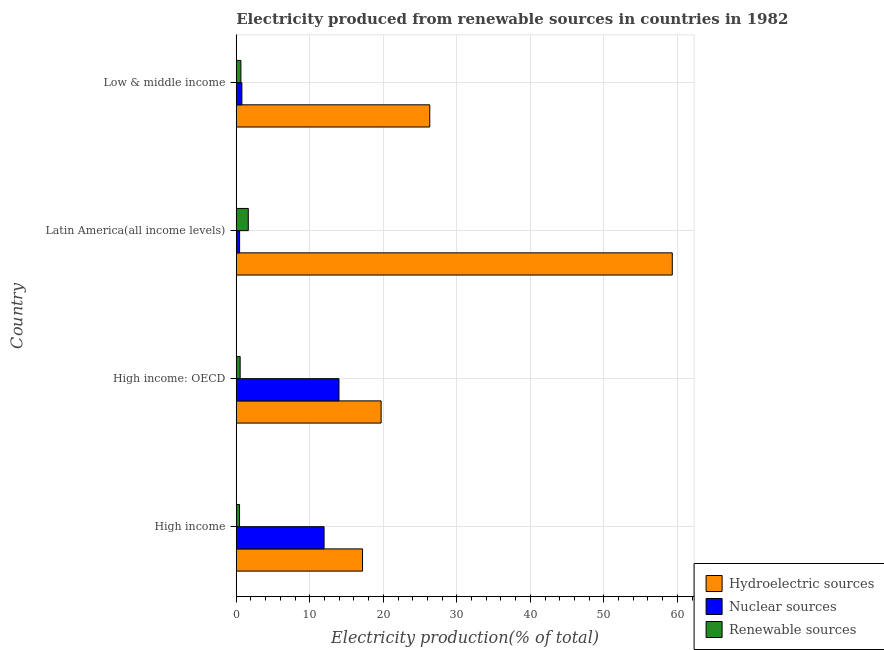How many different coloured bars are there?
Offer a very short reply. 3. Are the number of bars per tick equal to the number of legend labels?
Keep it short and to the point. Yes. Are the number of bars on each tick of the Y-axis equal?
Offer a very short reply. Yes. How many bars are there on the 3rd tick from the top?
Your response must be concise. 3. What is the label of the 4th group of bars from the top?
Make the answer very short. High income. In how many cases, is the number of bars for a given country not equal to the number of legend labels?
Ensure brevity in your answer.  0. What is the percentage of electricity produced by hydroelectric sources in High income?
Provide a succinct answer. 17.18. Across all countries, what is the maximum percentage of electricity produced by hydroelectric sources?
Ensure brevity in your answer.  59.31. Across all countries, what is the minimum percentage of electricity produced by renewable sources?
Give a very brief answer. 0.45. In which country was the percentage of electricity produced by renewable sources maximum?
Offer a very short reply. Latin America(all income levels). What is the total percentage of electricity produced by nuclear sources in the graph?
Ensure brevity in your answer.  27.14. What is the difference between the percentage of electricity produced by hydroelectric sources in High income and that in Latin America(all income levels)?
Provide a succinct answer. -42.13. What is the difference between the percentage of electricity produced by renewable sources in High income and the percentage of electricity produced by hydroelectric sources in Low & middle income?
Provide a succinct answer. -25.87. What is the average percentage of electricity produced by hydroelectric sources per country?
Provide a succinct answer. 30.63. What is the difference between the percentage of electricity produced by nuclear sources and percentage of electricity produced by hydroelectric sources in High income: OECD?
Your response must be concise. -5.73. What is the ratio of the percentage of electricity produced by hydroelectric sources in High income: OECD to that in Low & middle income?
Provide a short and direct response. 0.75. What is the difference between the highest and the second highest percentage of electricity produced by nuclear sources?
Keep it short and to the point. 2.03. What is the difference between the highest and the lowest percentage of electricity produced by renewable sources?
Give a very brief answer. 1.19. In how many countries, is the percentage of electricity produced by nuclear sources greater than the average percentage of electricity produced by nuclear sources taken over all countries?
Your answer should be compact. 2. What does the 2nd bar from the top in Latin America(all income levels) represents?
Provide a short and direct response. Nuclear sources. What does the 3rd bar from the bottom in High income represents?
Give a very brief answer. Renewable sources. How many bars are there?
Keep it short and to the point. 12. Are all the bars in the graph horizontal?
Provide a short and direct response. Yes. How many legend labels are there?
Give a very brief answer. 3. What is the title of the graph?
Offer a very short reply. Electricity produced from renewable sources in countries in 1982. What is the Electricity production(% of total) in Hydroelectric sources in High income?
Provide a succinct answer. 17.18. What is the Electricity production(% of total) of Nuclear sources in High income?
Give a very brief answer. 11.95. What is the Electricity production(% of total) in Renewable sources in High income?
Your answer should be very brief. 0.45. What is the Electricity production(% of total) of Hydroelectric sources in High income: OECD?
Your answer should be compact. 19.7. What is the Electricity production(% of total) of Nuclear sources in High income: OECD?
Your answer should be very brief. 13.97. What is the Electricity production(% of total) of Renewable sources in High income: OECD?
Provide a succinct answer. 0.53. What is the Electricity production(% of total) in Hydroelectric sources in Latin America(all income levels)?
Keep it short and to the point. 59.31. What is the Electricity production(% of total) in Nuclear sources in Latin America(all income levels)?
Provide a short and direct response. 0.45. What is the Electricity production(% of total) of Renewable sources in Latin America(all income levels)?
Offer a terse response. 1.64. What is the Electricity production(% of total) in Hydroelectric sources in Low & middle income?
Keep it short and to the point. 26.32. What is the Electricity production(% of total) of Nuclear sources in Low & middle income?
Your response must be concise. 0.77. What is the Electricity production(% of total) in Renewable sources in Low & middle income?
Your response must be concise. 0.63. Across all countries, what is the maximum Electricity production(% of total) of Hydroelectric sources?
Offer a terse response. 59.31. Across all countries, what is the maximum Electricity production(% of total) in Nuclear sources?
Offer a very short reply. 13.97. Across all countries, what is the maximum Electricity production(% of total) of Renewable sources?
Keep it short and to the point. 1.64. Across all countries, what is the minimum Electricity production(% of total) of Hydroelectric sources?
Offer a terse response. 17.18. Across all countries, what is the minimum Electricity production(% of total) of Nuclear sources?
Offer a terse response. 0.45. Across all countries, what is the minimum Electricity production(% of total) in Renewable sources?
Give a very brief answer. 0.45. What is the total Electricity production(% of total) of Hydroelectric sources in the graph?
Give a very brief answer. 122.51. What is the total Electricity production(% of total) of Nuclear sources in the graph?
Your answer should be very brief. 27.14. What is the total Electricity production(% of total) of Renewable sources in the graph?
Offer a very short reply. 3.25. What is the difference between the Electricity production(% of total) in Hydroelectric sources in High income and that in High income: OECD?
Your response must be concise. -2.53. What is the difference between the Electricity production(% of total) in Nuclear sources in High income and that in High income: OECD?
Your response must be concise. -2.03. What is the difference between the Electricity production(% of total) of Renewable sources in High income and that in High income: OECD?
Your response must be concise. -0.08. What is the difference between the Electricity production(% of total) in Hydroelectric sources in High income and that in Latin America(all income levels)?
Your answer should be compact. -42.13. What is the difference between the Electricity production(% of total) of Nuclear sources in High income and that in Latin America(all income levels)?
Offer a very short reply. 11.49. What is the difference between the Electricity production(% of total) in Renewable sources in High income and that in Latin America(all income levels)?
Ensure brevity in your answer.  -1.19. What is the difference between the Electricity production(% of total) of Hydroelectric sources in High income and that in Low & middle income?
Ensure brevity in your answer.  -9.14. What is the difference between the Electricity production(% of total) in Nuclear sources in High income and that in Low & middle income?
Give a very brief answer. 11.18. What is the difference between the Electricity production(% of total) in Renewable sources in High income and that in Low & middle income?
Offer a very short reply. -0.18. What is the difference between the Electricity production(% of total) of Hydroelectric sources in High income: OECD and that in Latin America(all income levels)?
Provide a short and direct response. -39.6. What is the difference between the Electricity production(% of total) of Nuclear sources in High income: OECD and that in Latin America(all income levels)?
Give a very brief answer. 13.52. What is the difference between the Electricity production(% of total) of Renewable sources in High income: OECD and that in Latin America(all income levels)?
Provide a short and direct response. -1.11. What is the difference between the Electricity production(% of total) of Hydroelectric sources in High income: OECD and that in Low & middle income?
Provide a short and direct response. -6.62. What is the difference between the Electricity production(% of total) in Nuclear sources in High income: OECD and that in Low & middle income?
Offer a very short reply. 13.21. What is the difference between the Electricity production(% of total) of Renewable sources in High income: OECD and that in Low & middle income?
Give a very brief answer. -0.1. What is the difference between the Electricity production(% of total) of Hydroelectric sources in Latin America(all income levels) and that in Low & middle income?
Keep it short and to the point. 32.99. What is the difference between the Electricity production(% of total) in Nuclear sources in Latin America(all income levels) and that in Low & middle income?
Offer a terse response. -0.31. What is the difference between the Electricity production(% of total) of Renewable sources in Latin America(all income levels) and that in Low & middle income?
Your answer should be compact. 1.01. What is the difference between the Electricity production(% of total) of Hydroelectric sources in High income and the Electricity production(% of total) of Nuclear sources in High income: OECD?
Ensure brevity in your answer.  3.2. What is the difference between the Electricity production(% of total) of Hydroelectric sources in High income and the Electricity production(% of total) of Renewable sources in High income: OECD?
Provide a succinct answer. 16.65. What is the difference between the Electricity production(% of total) in Nuclear sources in High income and the Electricity production(% of total) in Renewable sources in High income: OECD?
Your answer should be compact. 11.41. What is the difference between the Electricity production(% of total) of Hydroelectric sources in High income and the Electricity production(% of total) of Nuclear sources in Latin America(all income levels)?
Offer a very short reply. 16.72. What is the difference between the Electricity production(% of total) in Hydroelectric sources in High income and the Electricity production(% of total) in Renewable sources in Latin America(all income levels)?
Provide a succinct answer. 15.54. What is the difference between the Electricity production(% of total) in Nuclear sources in High income and the Electricity production(% of total) in Renewable sources in Latin America(all income levels)?
Offer a very short reply. 10.31. What is the difference between the Electricity production(% of total) in Hydroelectric sources in High income and the Electricity production(% of total) in Nuclear sources in Low & middle income?
Provide a succinct answer. 16.41. What is the difference between the Electricity production(% of total) in Hydroelectric sources in High income and the Electricity production(% of total) in Renewable sources in Low & middle income?
Offer a very short reply. 16.55. What is the difference between the Electricity production(% of total) of Nuclear sources in High income and the Electricity production(% of total) of Renewable sources in Low & middle income?
Ensure brevity in your answer.  11.32. What is the difference between the Electricity production(% of total) in Hydroelectric sources in High income: OECD and the Electricity production(% of total) in Nuclear sources in Latin America(all income levels)?
Keep it short and to the point. 19.25. What is the difference between the Electricity production(% of total) of Hydroelectric sources in High income: OECD and the Electricity production(% of total) of Renewable sources in Latin America(all income levels)?
Make the answer very short. 18.07. What is the difference between the Electricity production(% of total) in Nuclear sources in High income: OECD and the Electricity production(% of total) in Renewable sources in Latin America(all income levels)?
Ensure brevity in your answer.  12.33. What is the difference between the Electricity production(% of total) in Hydroelectric sources in High income: OECD and the Electricity production(% of total) in Nuclear sources in Low & middle income?
Your response must be concise. 18.94. What is the difference between the Electricity production(% of total) of Hydroelectric sources in High income: OECD and the Electricity production(% of total) of Renewable sources in Low & middle income?
Provide a short and direct response. 19.07. What is the difference between the Electricity production(% of total) in Nuclear sources in High income: OECD and the Electricity production(% of total) in Renewable sources in Low & middle income?
Your response must be concise. 13.34. What is the difference between the Electricity production(% of total) in Hydroelectric sources in Latin America(all income levels) and the Electricity production(% of total) in Nuclear sources in Low & middle income?
Provide a succinct answer. 58.54. What is the difference between the Electricity production(% of total) in Hydroelectric sources in Latin America(all income levels) and the Electricity production(% of total) in Renewable sources in Low & middle income?
Offer a very short reply. 58.68. What is the difference between the Electricity production(% of total) in Nuclear sources in Latin America(all income levels) and the Electricity production(% of total) in Renewable sources in Low & middle income?
Your answer should be very brief. -0.18. What is the average Electricity production(% of total) of Hydroelectric sources per country?
Ensure brevity in your answer.  30.63. What is the average Electricity production(% of total) of Nuclear sources per country?
Your answer should be very brief. 6.78. What is the average Electricity production(% of total) in Renewable sources per country?
Offer a very short reply. 0.81. What is the difference between the Electricity production(% of total) in Hydroelectric sources and Electricity production(% of total) in Nuclear sources in High income?
Provide a short and direct response. 5.23. What is the difference between the Electricity production(% of total) in Hydroelectric sources and Electricity production(% of total) in Renewable sources in High income?
Offer a terse response. 16.73. What is the difference between the Electricity production(% of total) in Nuclear sources and Electricity production(% of total) in Renewable sources in High income?
Provide a short and direct response. 11.5. What is the difference between the Electricity production(% of total) in Hydroelectric sources and Electricity production(% of total) in Nuclear sources in High income: OECD?
Provide a short and direct response. 5.73. What is the difference between the Electricity production(% of total) of Hydroelectric sources and Electricity production(% of total) of Renewable sources in High income: OECD?
Offer a terse response. 19.17. What is the difference between the Electricity production(% of total) of Nuclear sources and Electricity production(% of total) of Renewable sources in High income: OECD?
Keep it short and to the point. 13.44. What is the difference between the Electricity production(% of total) in Hydroelectric sources and Electricity production(% of total) in Nuclear sources in Latin America(all income levels)?
Your answer should be compact. 58.85. What is the difference between the Electricity production(% of total) of Hydroelectric sources and Electricity production(% of total) of Renewable sources in Latin America(all income levels)?
Your answer should be compact. 57.67. What is the difference between the Electricity production(% of total) in Nuclear sources and Electricity production(% of total) in Renewable sources in Latin America(all income levels)?
Give a very brief answer. -1.19. What is the difference between the Electricity production(% of total) in Hydroelectric sources and Electricity production(% of total) in Nuclear sources in Low & middle income?
Provide a succinct answer. 25.55. What is the difference between the Electricity production(% of total) of Hydroelectric sources and Electricity production(% of total) of Renewable sources in Low & middle income?
Ensure brevity in your answer.  25.69. What is the difference between the Electricity production(% of total) of Nuclear sources and Electricity production(% of total) of Renewable sources in Low & middle income?
Ensure brevity in your answer.  0.14. What is the ratio of the Electricity production(% of total) in Hydroelectric sources in High income to that in High income: OECD?
Your response must be concise. 0.87. What is the ratio of the Electricity production(% of total) of Nuclear sources in High income to that in High income: OECD?
Ensure brevity in your answer.  0.85. What is the ratio of the Electricity production(% of total) in Renewable sources in High income to that in High income: OECD?
Ensure brevity in your answer.  0.84. What is the ratio of the Electricity production(% of total) of Hydroelectric sources in High income to that in Latin America(all income levels)?
Give a very brief answer. 0.29. What is the ratio of the Electricity production(% of total) in Nuclear sources in High income to that in Latin America(all income levels)?
Your answer should be very brief. 26.32. What is the ratio of the Electricity production(% of total) in Renewable sources in High income to that in Latin America(all income levels)?
Provide a short and direct response. 0.27. What is the ratio of the Electricity production(% of total) of Hydroelectric sources in High income to that in Low & middle income?
Your answer should be compact. 0.65. What is the ratio of the Electricity production(% of total) of Nuclear sources in High income to that in Low & middle income?
Give a very brief answer. 15.61. What is the ratio of the Electricity production(% of total) in Renewable sources in High income to that in Low & middle income?
Make the answer very short. 0.71. What is the ratio of the Electricity production(% of total) of Hydroelectric sources in High income: OECD to that in Latin America(all income levels)?
Make the answer very short. 0.33. What is the ratio of the Electricity production(% of total) in Nuclear sources in High income: OECD to that in Latin America(all income levels)?
Give a very brief answer. 30.79. What is the ratio of the Electricity production(% of total) of Renewable sources in High income: OECD to that in Latin America(all income levels)?
Your answer should be compact. 0.32. What is the ratio of the Electricity production(% of total) in Hydroelectric sources in High income: OECD to that in Low & middle income?
Make the answer very short. 0.75. What is the ratio of the Electricity production(% of total) of Nuclear sources in High income: OECD to that in Low & middle income?
Your response must be concise. 18.26. What is the ratio of the Electricity production(% of total) in Renewable sources in High income: OECD to that in Low & middle income?
Your answer should be very brief. 0.84. What is the ratio of the Electricity production(% of total) of Hydroelectric sources in Latin America(all income levels) to that in Low & middle income?
Your answer should be very brief. 2.25. What is the ratio of the Electricity production(% of total) of Nuclear sources in Latin America(all income levels) to that in Low & middle income?
Ensure brevity in your answer.  0.59. What is the ratio of the Electricity production(% of total) in Renewable sources in Latin America(all income levels) to that in Low & middle income?
Ensure brevity in your answer.  2.6. What is the difference between the highest and the second highest Electricity production(% of total) in Hydroelectric sources?
Offer a very short reply. 32.99. What is the difference between the highest and the second highest Electricity production(% of total) in Nuclear sources?
Your answer should be compact. 2.03. What is the difference between the highest and the second highest Electricity production(% of total) in Renewable sources?
Provide a short and direct response. 1.01. What is the difference between the highest and the lowest Electricity production(% of total) of Hydroelectric sources?
Offer a terse response. 42.13. What is the difference between the highest and the lowest Electricity production(% of total) of Nuclear sources?
Keep it short and to the point. 13.52. What is the difference between the highest and the lowest Electricity production(% of total) in Renewable sources?
Give a very brief answer. 1.19. 